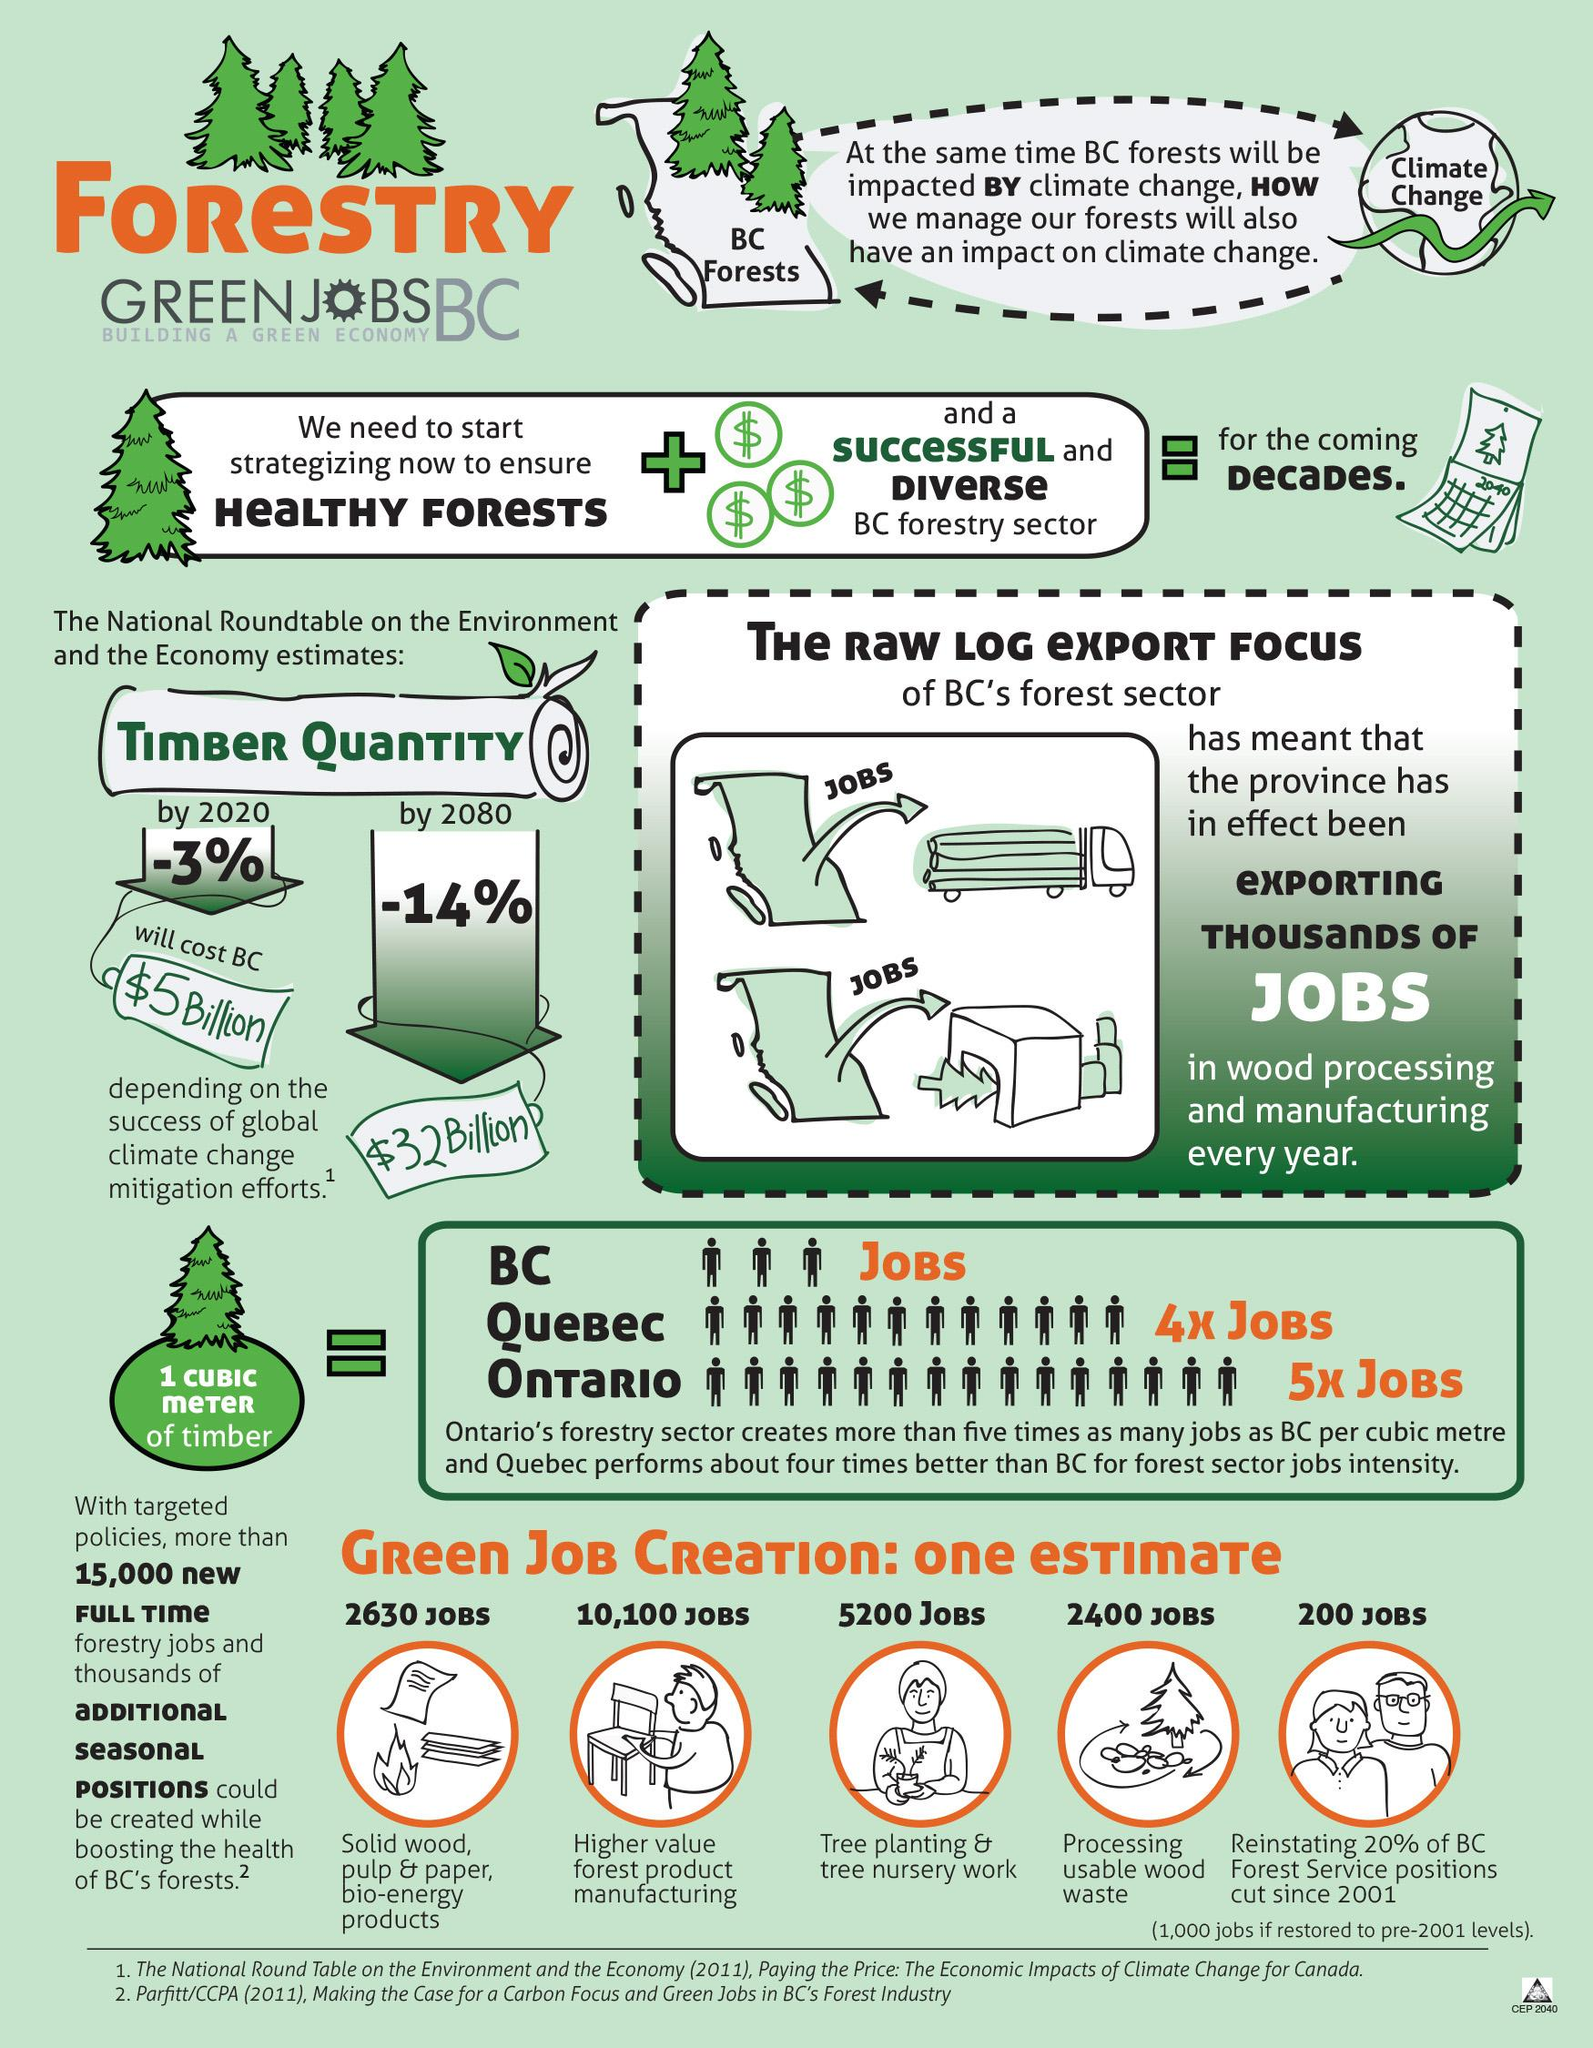Outline some significant characteristics in this image. According to the information provided, the number of jobs that can be created through planting and nursery work is estimated to be 5,200 jobs. According to the report, the sector that is projected to create the highest number of green jobs is higher value forest product manufacturing. 